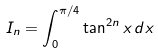<formula> <loc_0><loc_0><loc_500><loc_500>I _ { n } = \int _ { 0 } ^ { \pi / 4 } \tan ^ { 2 n } x \, d x</formula> 